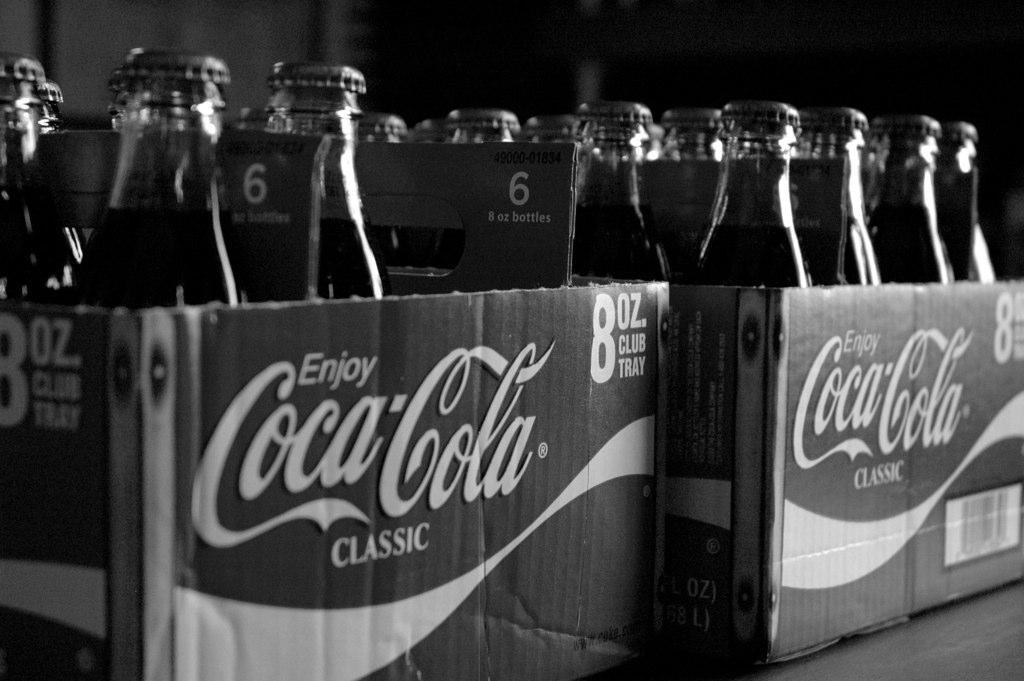How many boxes are visible in the image? There are two boxes in the image. What are the boxes filled with? The boxes are filled with bottles. What is the color scheme of the image? The image is black and white. What type of drug is being stored in the boxes in the image? There is no indication of any drug in the image; it only shows two boxes filled with bottles. 